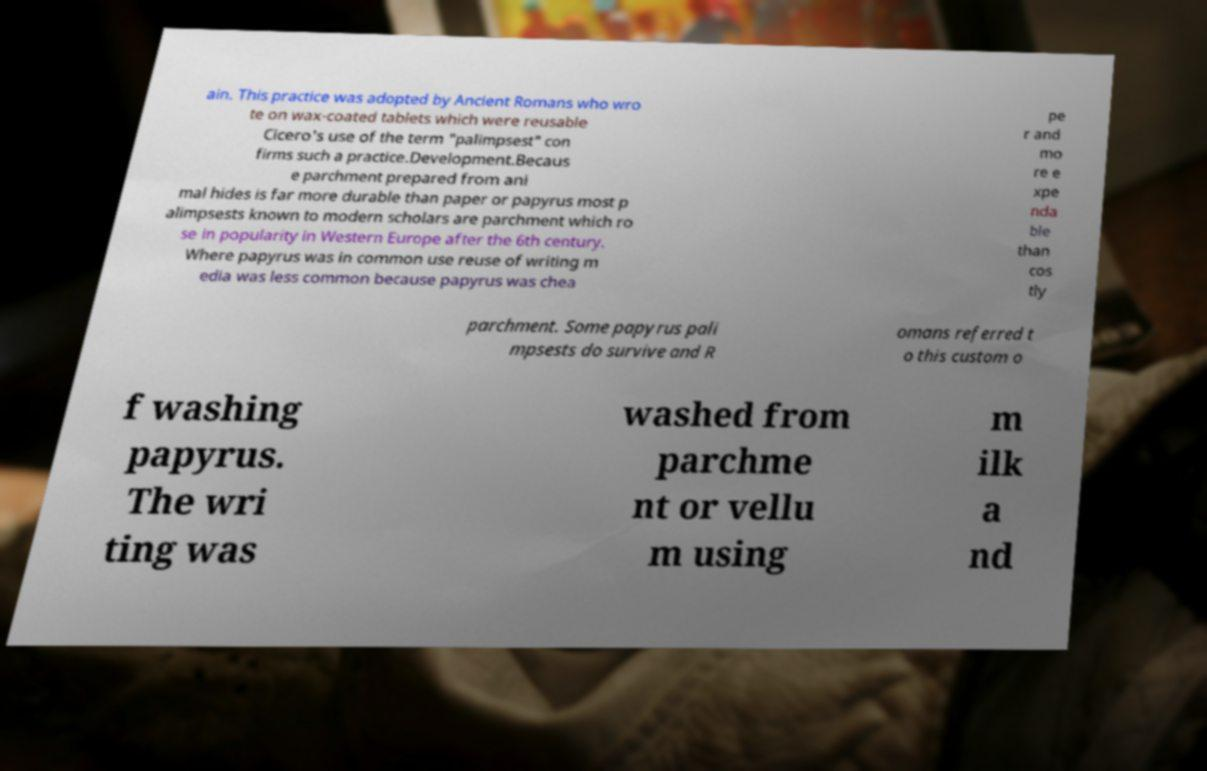Please read and relay the text visible in this image. What does it say? ain. This practice was adopted by Ancient Romans who wro te on wax-coated tablets which were reusable Cicero's use of the term "palimpsest" con firms such a practice.Development.Becaus e parchment prepared from ani mal hides is far more durable than paper or papyrus most p alimpsests known to modern scholars are parchment which ro se in popularity in Western Europe after the 6th century. Where papyrus was in common use reuse of writing m edia was less common because papyrus was chea pe r and mo re e xpe nda ble than cos tly parchment. Some papyrus pali mpsests do survive and R omans referred t o this custom o f washing papyrus. The wri ting was washed from parchme nt or vellu m using m ilk a nd 